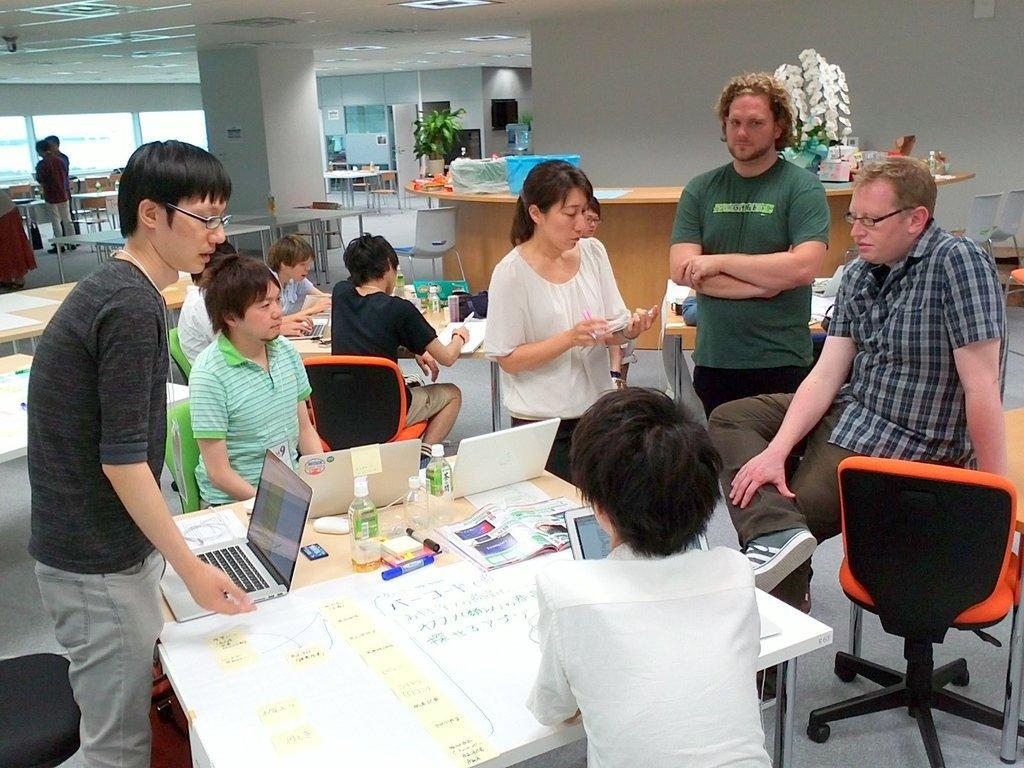Can you describe this image briefly? In this picture there are some people sitting on the chair around the table on which there are some things and behind them there is a desk and some other chairs and tables. 